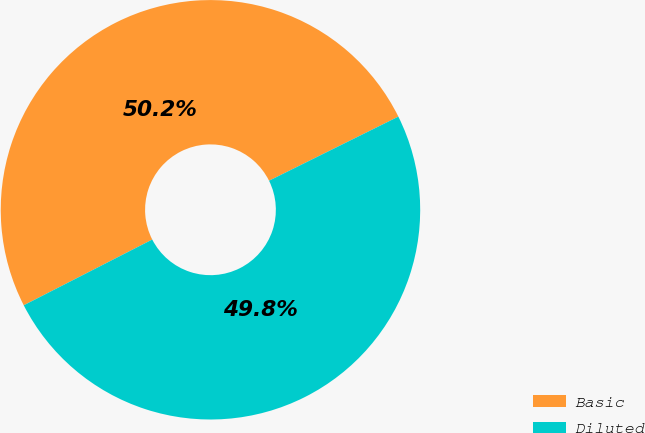Convert chart to OTSL. <chart><loc_0><loc_0><loc_500><loc_500><pie_chart><fcel>Basic<fcel>Diluted<nl><fcel>50.2%<fcel>49.8%<nl></chart> 